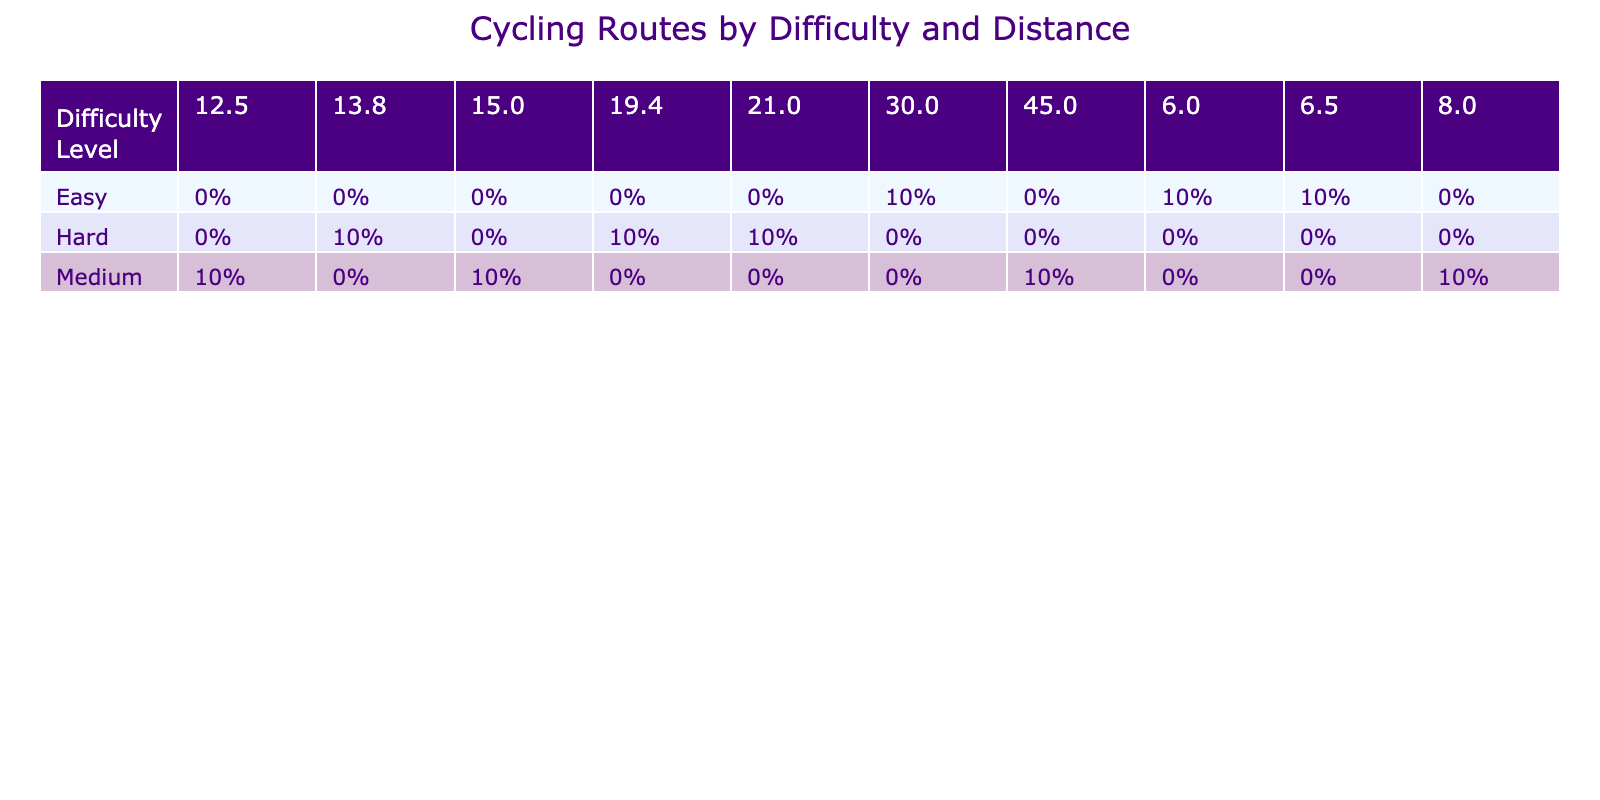What is the distance of the shortest route categorized as Hard? The Hard routes listed are Alpe d'Huez (13.8 km), Col de la Madeleine (19.4 km), and Mont Ventoux (21.0 km). Among these, Alpe d'Huez has the shortest distance of 13.8 km.
Answer: 13.8 km How many routes are classified as Easy? By looking at the table, the Easy routes are Lake Tahoe Loop (30.0 km), Golden Gate Park Loop (6.5 km), and Central Park Loop (6.0 km). This means there are a total of 3 Easy routes.
Answer: 3 What is the average distance of Medium difficulty routes? The Medium routes are Moulton Hill (8.0 km), Velodrome de la Piste (12.5 km), Coastal Highway (45.0 km), and Cotswold Hills (15.0 km). First, we sum these distances: 8.0 + 12.5 + 45.0 + 15.0 = 80.5 km. There are 4 Medium routes, so the average is 80.5 / 4 = 20.125 km.
Answer: 20.125 km Is there any route classified as Easy with a distance greater than 10 km? The Easy routes are Lake Tahoe Loop (30.0 km), Golden Gate Park Loop (6.5 km), and Central Park Loop (6.0 km). The only Easy route with a distance greater than 10 km is Lake Tahoe Loop at 30.0 km.
Answer: Yes Which difficulty level has the longest average distance? First, we consider the distances for each difficulty: Hard routes are 13.8, 19.4, and 21.0 km with an average of (13.8 + 19.4 + 21.0) / 3 = 18.14 km. Medium routes are 8.0, 12.5, 45.0, and 15.0 km; their average is (8.0 + 12.5 + 45.0 + 15.0) / 4 = 20.125 km. Easy routes are 30.0, 6.5, and 6.0 km, giving an average of (30.0 + 6.5 + 6.0) / 3 = 14.5 km. The highest average is for Medium routes at 20.125 km.
Answer: Medium What is the total number of routes listed? By counting all routes in the table, we have 10 routes in total.
Answer: 10 Is Coastal Highway the only Medium route that has a distance greater than 40 km? Checking the Medium routes, we have Moulton Hill (8.0 km), Velodrome de la Piste (12.5 km), Coastal Highway (45.0 km), and Cotswold Hills (15.0 km). The only route over 40 km is Coastal Highway, making the statement true.
Answer: Yes How many Hard routes are over 15 km? The Hard routes are Alpe d'Huez (13.8 km), Col de la Madeleine (19.4 km), and Mont Ventoux (21.0 km). Among these, Col de la Madeleine and Mont Ventoux are over 15 km, giving a count of 2.
Answer: 2 